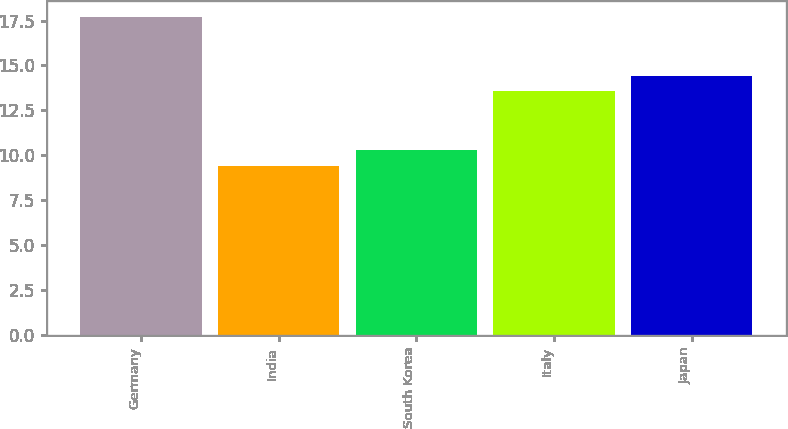Convert chart to OTSL. <chart><loc_0><loc_0><loc_500><loc_500><bar_chart><fcel>Germany<fcel>India<fcel>South Korea<fcel>Italy<fcel>Japan<nl><fcel>17.7<fcel>9.4<fcel>10.3<fcel>13.6<fcel>14.43<nl></chart> 